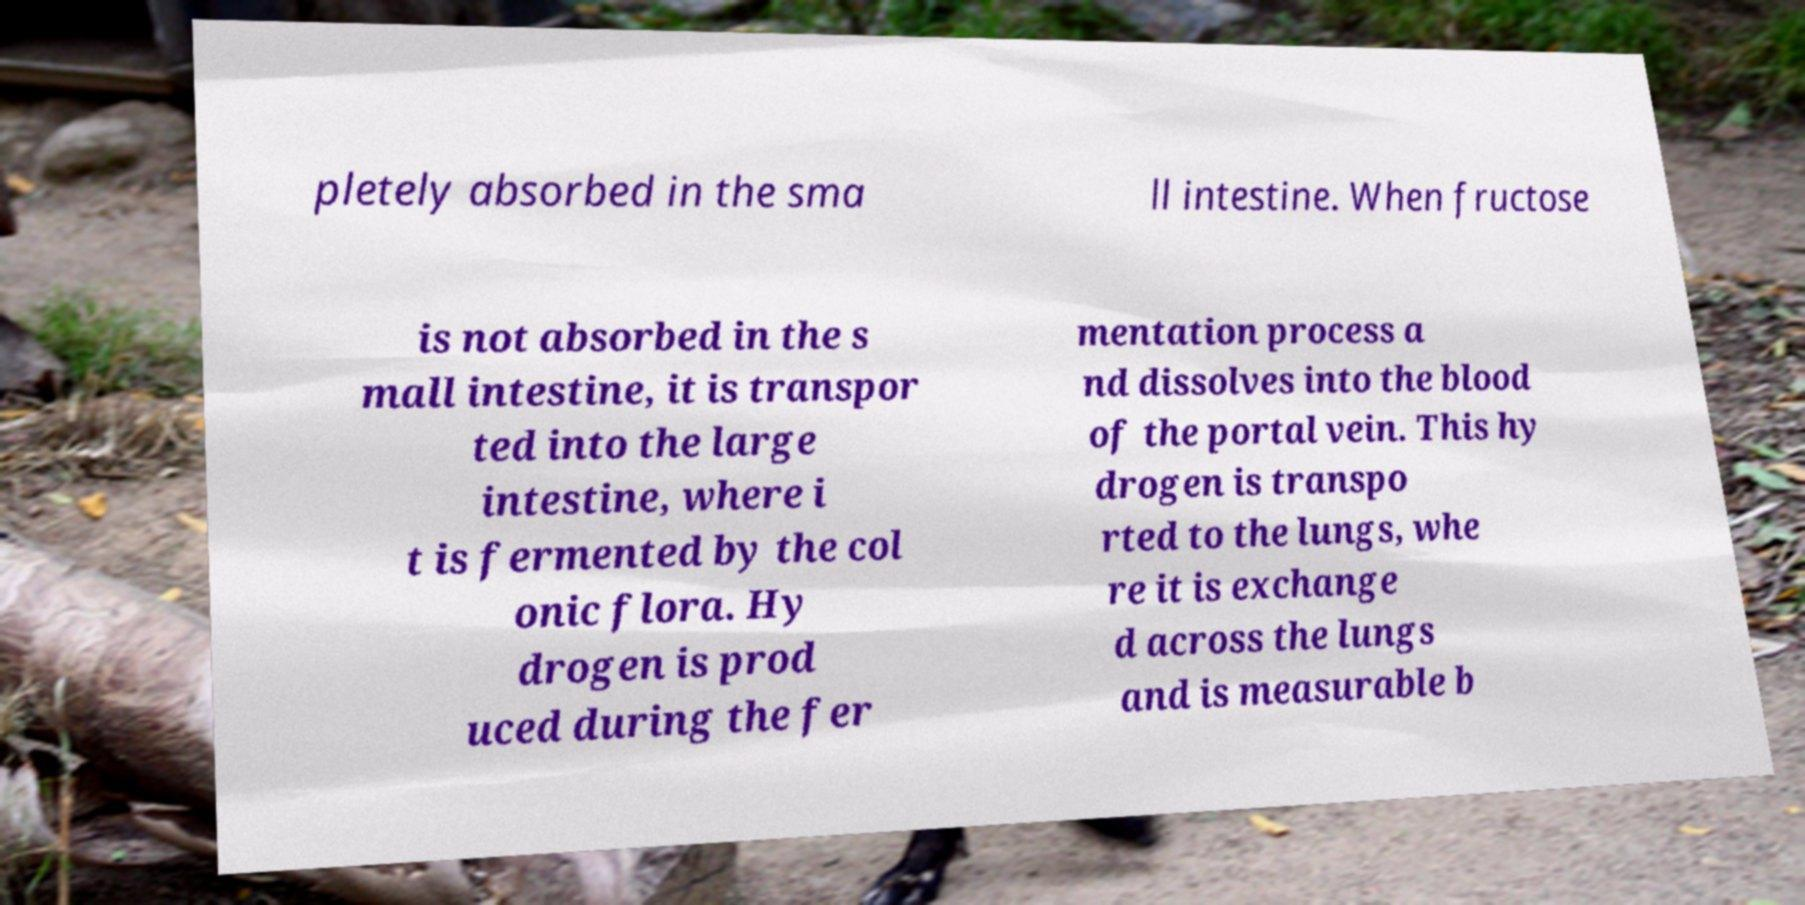Please read and relay the text visible in this image. What does it say? pletely absorbed in the sma ll intestine. When fructose is not absorbed in the s mall intestine, it is transpor ted into the large intestine, where i t is fermented by the col onic flora. Hy drogen is prod uced during the fer mentation process a nd dissolves into the blood of the portal vein. This hy drogen is transpo rted to the lungs, whe re it is exchange d across the lungs and is measurable b 